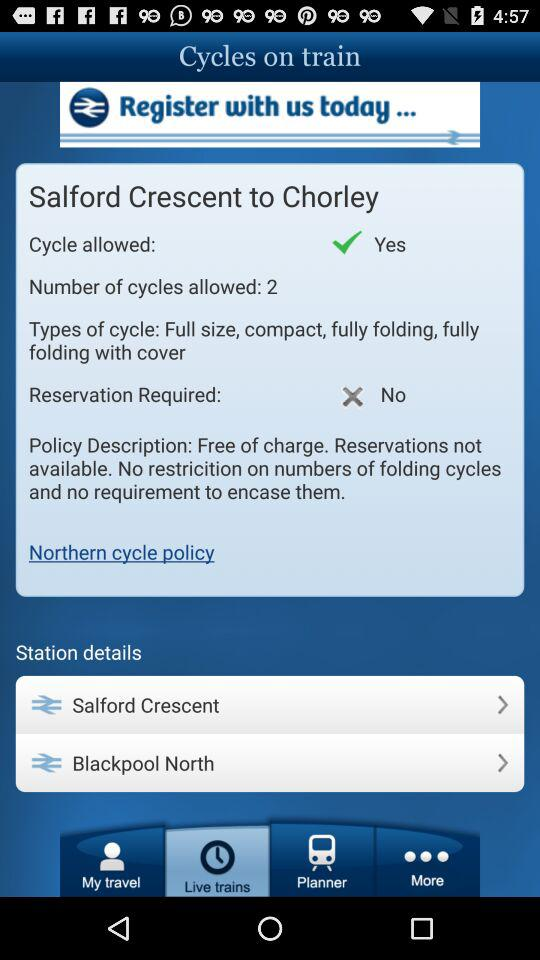How many cycles are allowed at Chorley?
Answer the question using a single word or phrase. 2 